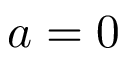<formula> <loc_0><loc_0><loc_500><loc_500>a = 0</formula> 